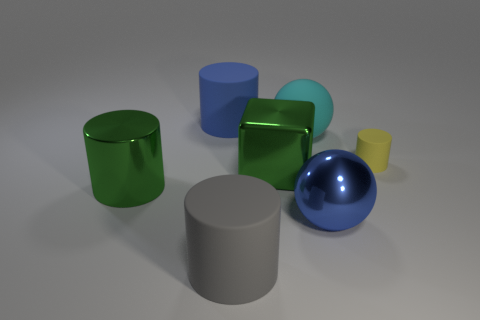Add 3 shiny spheres. How many objects exist? 10 Subtract all cylinders. How many objects are left? 3 Subtract 0 cyan cubes. How many objects are left? 7 Subtract all green cylinders. Subtract all big gray matte cylinders. How many objects are left? 5 Add 3 large cyan matte balls. How many large cyan matte balls are left? 4 Add 2 brown rubber cubes. How many brown rubber cubes exist? 2 